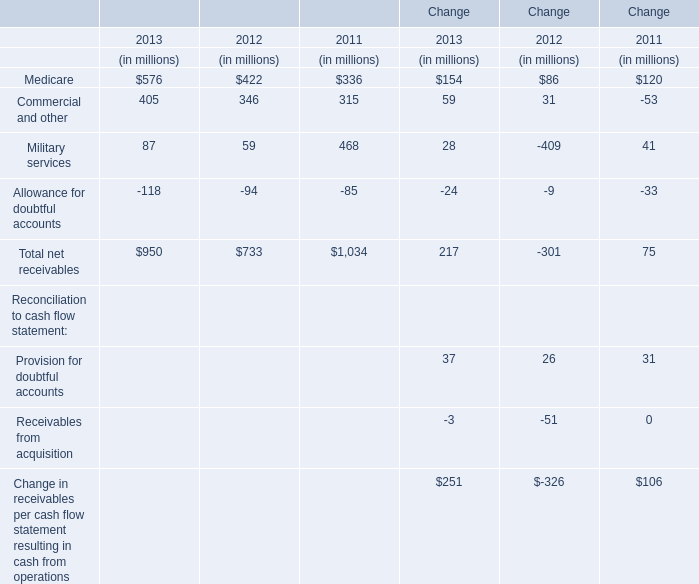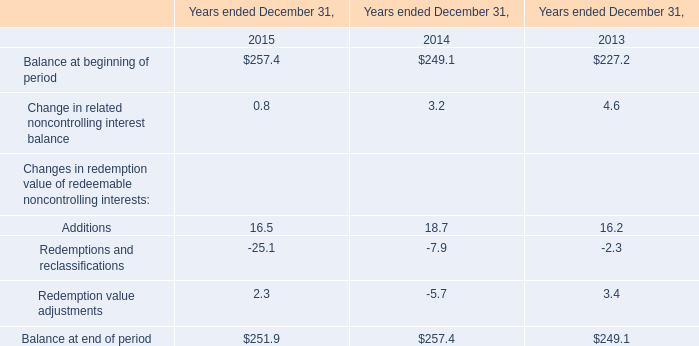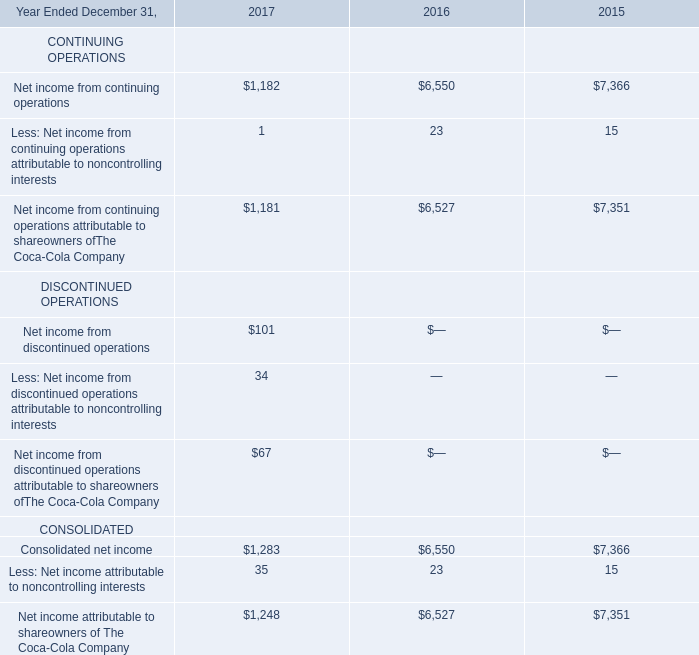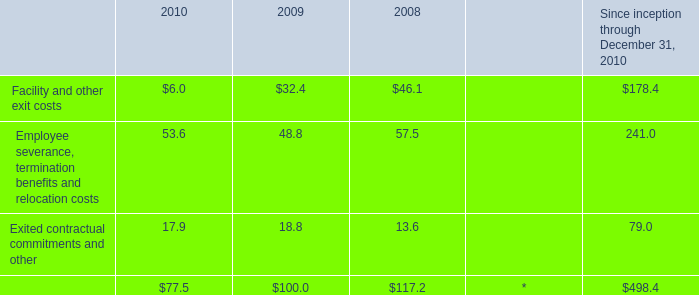What is the ratio of all 2013 that are smaller than 100 to the sum of 2013, in 2013? 
Computations: ((87 - 118) / (((87 - 118) + 576) + 405))
Answer: -0.03263. 